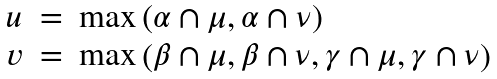<formula> <loc_0><loc_0><loc_500><loc_500>\begin{array} { l l l } u & = & \max \left ( \alpha \cap \mu , \alpha \cap \nu \right ) \\ v & = & \max \left ( \beta \cap \mu , \beta \cap \nu , \gamma \cap \mu , \gamma \cap \nu \right ) \end{array}</formula> 